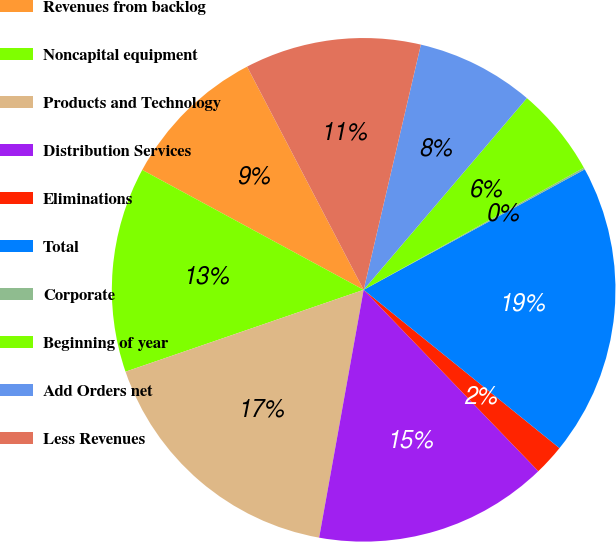<chart> <loc_0><loc_0><loc_500><loc_500><pie_chart><fcel>Revenues from backlog<fcel>Noncapital equipment<fcel>Products and Technology<fcel>Distribution Services<fcel>Eliminations<fcel>Total<fcel>Corporate<fcel>Beginning of year<fcel>Add Orders net<fcel>Less Revenues<nl><fcel>9.44%<fcel>13.17%<fcel>16.9%<fcel>15.03%<fcel>1.98%<fcel>18.76%<fcel>0.12%<fcel>5.71%<fcel>7.58%<fcel>11.31%<nl></chart> 